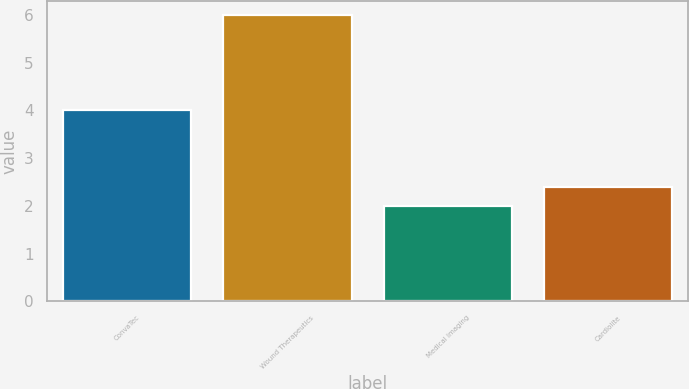Convert chart. <chart><loc_0><loc_0><loc_500><loc_500><bar_chart><fcel>ConvaTec<fcel>Wound Therapeutics<fcel>Medical Imaging<fcel>Cardiolite<nl><fcel>4<fcel>6<fcel>2<fcel>2.4<nl></chart> 